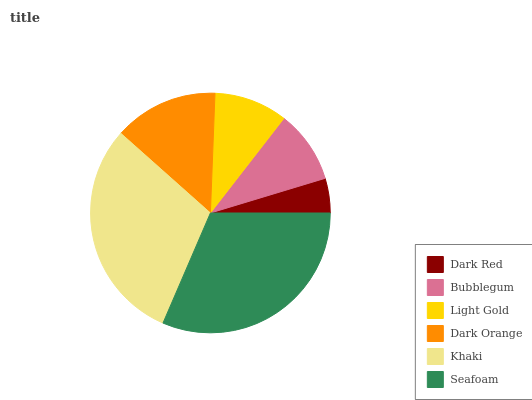Is Dark Red the minimum?
Answer yes or no. Yes. Is Seafoam the maximum?
Answer yes or no. Yes. Is Bubblegum the minimum?
Answer yes or no. No. Is Bubblegum the maximum?
Answer yes or no. No. Is Bubblegum greater than Dark Red?
Answer yes or no. Yes. Is Dark Red less than Bubblegum?
Answer yes or no. Yes. Is Dark Red greater than Bubblegum?
Answer yes or no. No. Is Bubblegum less than Dark Red?
Answer yes or no. No. Is Dark Orange the high median?
Answer yes or no. Yes. Is Light Gold the low median?
Answer yes or no. Yes. Is Khaki the high median?
Answer yes or no. No. Is Khaki the low median?
Answer yes or no. No. 